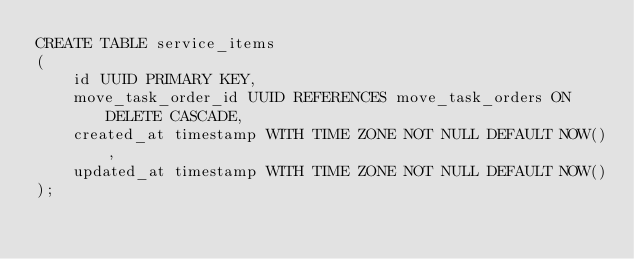Convert code to text. <code><loc_0><loc_0><loc_500><loc_500><_SQL_>CREATE TABLE service_items
(
	id UUID PRIMARY KEY,
	move_task_order_id UUID REFERENCES move_task_orders ON DELETE CASCADE,
    created_at timestamp WITH TIME ZONE NOT NULL DEFAULT NOW(),
    updated_at timestamp WITH TIME ZONE NOT NULL DEFAULT NOW()
);
</code> 